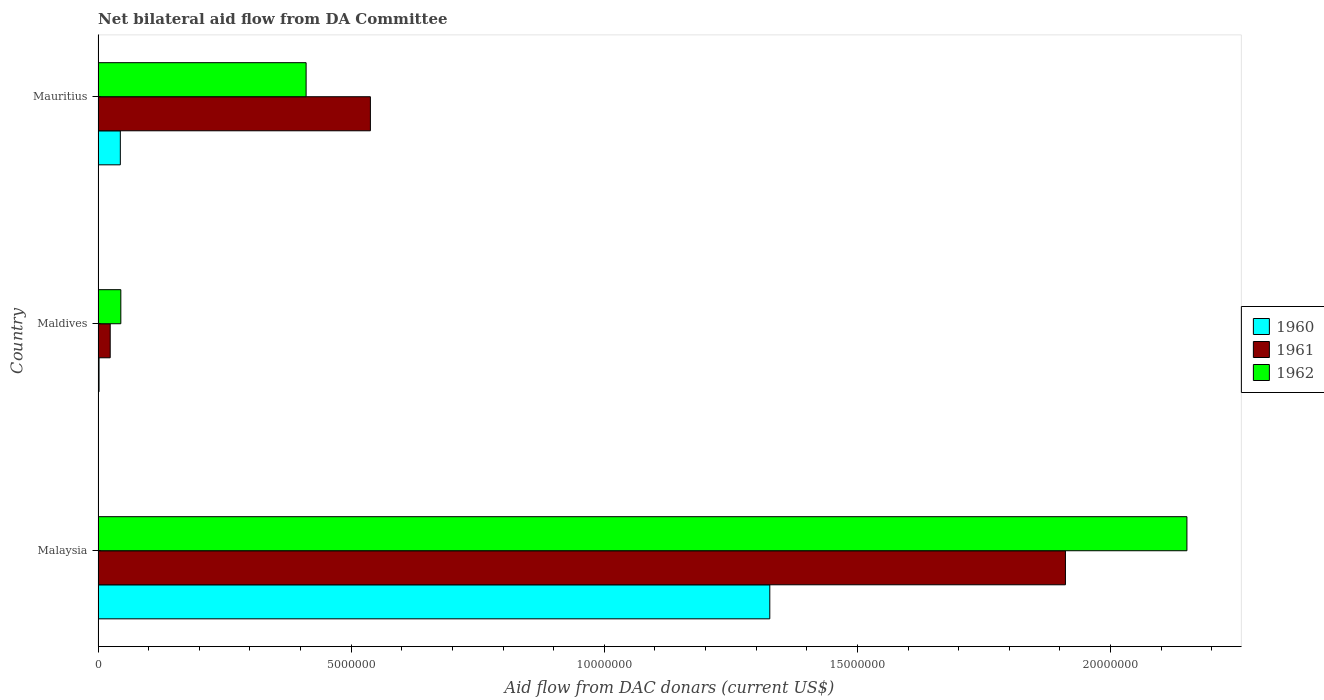How many different coloured bars are there?
Your answer should be compact. 3. How many groups of bars are there?
Your answer should be very brief. 3. How many bars are there on the 3rd tick from the top?
Keep it short and to the point. 3. What is the label of the 3rd group of bars from the top?
Keep it short and to the point. Malaysia. What is the aid flow in in 1962 in Mauritius?
Provide a succinct answer. 4.11e+06. Across all countries, what is the maximum aid flow in in 1960?
Provide a succinct answer. 1.33e+07. In which country was the aid flow in in 1960 maximum?
Give a very brief answer. Malaysia. In which country was the aid flow in in 1960 minimum?
Give a very brief answer. Maldives. What is the total aid flow in in 1961 in the graph?
Your answer should be compact. 2.47e+07. What is the difference between the aid flow in in 1960 in Maldives and that in Mauritius?
Provide a succinct answer. -4.20e+05. What is the difference between the aid flow in in 1961 in Mauritius and the aid flow in in 1960 in Malaysia?
Your answer should be compact. -7.89e+06. What is the average aid flow in in 1961 per country?
Ensure brevity in your answer.  8.24e+06. What is the difference between the aid flow in in 1960 and aid flow in in 1961 in Malaysia?
Offer a very short reply. -5.84e+06. In how many countries, is the aid flow in in 1962 greater than 2000000 US$?
Make the answer very short. 2. What is the ratio of the aid flow in in 1961 in Malaysia to that in Mauritius?
Provide a succinct answer. 3.55. Is the aid flow in in 1962 in Maldives less than that in Mauritius?
Keep it short and to the point. Yes. What is the difference between the highest and the second highest aid flow in in 1960?
Your answer should be very brief. 1.28e+07. What is the difference between the highest and the lowest aid flow in in 1962?
Your response must be concise. 2.11e+07. What does the 1st bar from the bottom in Malaysia represents?
Keep it short and to the point. 1960. Are all the bars in the graph horizontal?
Offer a terse response. Yes. Where does the legend appear in the graph?
Offer a terse response. Center right. What is the title of the graph?
Make the answer very short. Net bilateral aid flow from DA Committee. What is the label or title of the X-axis?
Offer a terse response. Aid flow from DAC donars (current US$). What is the label or title of the Y-axis?
Offer a very short reply. Country. What is the Aid flow from DAC donars (current US$) of 1960 in Malaysia?
Your answer should be compact. 1.33e+07. What is the Aid flow from DAC donars (current US$) in 1961 in Malaysia?
Your response must be concise. 1.91e+07. What is the Aid flow from DAC donars (current US$) in 1962 in Malaysia?
Provide a succinct answer. 2.15e+07. What is the Aid flow from DAC donars (current US$) of 1961 in Maldives?
Provide a short and direct response. 2.40e+05. What is the Aid flow from DAC donars (current US$) of 1961 in Mauritius?
Keep it short and to the point. 5.38e+06. What is the Aid flow from DAC donars (current US$) in 1962 in Mauritius?
Offer a very short reply. 4.11e+06. Across all countries, what is the maximum Aid flow from DAC donars (current US$) in 1960?
Your answer should be compact. 1.33e+07. Across all countries, what is the maximum Aid flow from DAC donars (current US$) in 1961?
Offer a very short reply. 1.91e+07. Across all countries, what is the maximum Aid flow from DAC donars (current US$) of 1962?
Provide a succinct answer. 2.15e+07. Across all countries, what is the minimum Aid flow from DAC donars (current US$) of 1960?
Provide a succinct answer. 2.00e+04. Across all countries, what is the minimum Aid flow from DAC donars (current US$) of 1962?
Your answer should be compact. 4.50e+05. What is the total Aid flow from DAC donars (current US$) of 1960 in the graph?
Keep it short and to the point. 1.37e+07. What is the total Aid flow from DAC donars (current US$) in 1961 in the graph?
Your answer should be very brief. 2.47e+07. What is the total Aid flow from DAC donars (current US$) in 1962 in the graph?
Offer a terse response. 2.61e+07. What is the difference between the Aid flow from DAC donars (current US$) of 1960 in Malaysia and that in Maldives?
Offer a terse response. 1.32e+07. What is the difference between the Aid flow from DAC donars (current US$) in 1961 in Malaysia and that in Maldives?
Offer a very short reply. 1.89e+07. What is the difference between the Aid flow from DAC donars (current US$) of 1962 in Malaysia and that in Maldives?
Make the answer very short. 2.11e+07. What is the difference between the Aid flow from DAC donars (current US$) of 1960 in Malaysia and that in Mauritius?
Keep it short and to the point. 1.28e+07. What is the difference between the Aid flow from DAC donars (current US$) of 1961 in Malaysia and that in Mauritius?
Give a very brief answer. 1.37e+07. What is the difference between the Aid flow from DAC donars (current US$) in 1962 in Malaysia and that in Mauritius?
Offer a terse response. 1.74e+07. What is the difference between the Aid flow from DAC donars (current US$) in 1960 in Maldives and that in Mauritius?
Offer a very short reply. -4.20e+05. What is the difference between the Aid flow from DAC donars (current US$) of 1961 in Maldives and that in Mauritius?
Your response must be concise. -5.14e+06. What is the difference between the Aid flow from DAC donars (current US$) in 1962 in Maldives and that in Mauritius?
Provide a succinct answer. -3.66e+06. What is the difference between the Aid flow from DAC donars (current US$) of 1960 in Malaysia and the Aid flow from DAC donars (current US$) of 1961 in Maldives?
Your answer should be compact. 1.30e+07. What is the difference between the Aid flow from DAC donars (current US$) in 1960 in Malaysia and the Aid flow from DAC donars (current US$) in 1962 in Maldives?
Provide a succinct answer. 1.28e+07. What is the difference between the Aid flow from DAC donars (current US$) in 1961 in Malaysia and the Aid flow from DAC donars (current US$) in 1962 in Maldives?
Your answer should be compact. 1.87e+07. What is the difference between the Aid flow from DAC donars (current US$) of 1960 in Malaysia and the Aid flow from DAC donars (current US$) of 1961 in Mauritius?
Provide a succinct answer. 7.89e+06. What is the difference between the Aid flow from DAC donars (current US$) in 1960 in Malaysia and the Aid flow from DAC donars (current US$) in 1962 in Mauritius?
Keep it short and to the point. 9.16e+06. What is the difference between the Aid flow from DAC donars (current US$) of 1961 in Malaysia and the Aid flow from DAC donars (current US$) of 1962 in Mauritius?
Your answer should be compact. 1.50e+07. What is the difference between the Aid flow from DAC donars (current US$) in 1960 in Maldives and the Aid flow from DAC donars (current US$) in 1961 in Mauritius?
Your answer should be very brief. -5.36e+06. What is the difference between the Aid flow from DAC donars (current US$) of 1960 in Maldives and the Aid flow from DAC donars (current US$) of 1962 in Mauritius?
Provide a succinct answer. -4.09e+06. What is the difference between the Aid flow from DAC donars (current US$) of 1961 in Maldives and the Aid flow from DAC donars (current US$) of 1962 in Mauritius?
Ensure brevity in your answer.  -3.87e+06. What is the average Aid flow from DAC donars (current US$) of 1960 per country?
Offer a terse response. 4.58e+06. What is the average Aid flow from DAC donars (current US$) in 1961 per country?
Offer a very short reply. 8.24e+06. What is the average Aid flow from DAC donars (current US$) in 1962 per country?
Ensure brevity in your answer.  8.69e+06. What is the difference between the Aid flow from DAC donars (current US$) in 1960 and Aid flow from DAC donars (current US$) in 1961 in Malaysia?
Give a very brief answer. -5.84e+06. What is the difference between the Aid flow from DAC donars (current US$) in 1960 and Aid flow from DAC donars (current US$) in 1962 in Malaysia?
Give a very brief answer. -8.24e+06. What is the difference between the Aid flow from DAC donars (current US$) of 1961 and Aid flow from DAC donars (current US$) of 1962 in Malaysia?
Offer a very short reply. -2.40e+06. What is the difference between the Aid flow from DAC donars (current US$) in 1960 and Aid flow from DAC donars (current US$) in 1962 in Maldives?
Provide a succinct answer. -4.30e+05. What is the difference between the Aid flow from DAC donars (current US$) in 1960 and Aid flow from DAC donars (current US$) in 1961 in Mauritius?
Your response must be concise. -4.94e+06. What is the difference between the Aid flow from DAC donars (current US$) in 1960 and Aid flow from DAC donars (current US$) in 1962 in Mauritius?
Give a very brief answer. -3.67e+06. What is the difference between the Aid flow from DAC donars (current US$) in 1961 and Aid flow from DAC donars (current US$) in 1962 in Mauritius?
Give a very brief answer. 1.27e+06. What is the ratio of the Aid flow from DAC donars (current US$) in 1960 in Malaysia to that in Maldives?
Make the answer very short. 663.5. What is the ratio of the Aid flow from DAC donars (current US$) of 1961 in Malaysia to that in Maldives?
Ensure brevity in your answer.  79.62. What is the ratio of the Aid flow from DAC donars (current US$) in 1962 in Malaysia to that in Maldives?
Give a very brief answer. 47.8. What is the ratio of the Aid flow from DAC donars (current US$) in 1960 in Malaysia to that in Mauritius?
Your answer should be compact. 30.16. What is the ratio of the Aid flow from DAC donars (current US$) in 1961 in Malaysia to that in Mauritius?
Your answer should be very brief. 3.55. What is the ratio of the Aid flow from DAC donars (current US$) in 1962 in Malaysia to that in Mauritius?
Keep it short and to the point. 5.23. What is the ratio of the Aid flow from DAC donars (current US$) of 1960 in Maldives to that in Mauritius?
Give a very brief answer. 0.05. What is the ratio of the Aid flow from DAC donars (current US$) in 1961 in Maldives to that in Mauritius?
Give a very brief answer. 0.04. What is the ratio of the Aid flow from DAC donars (current US$) of 1962 in Maldives to that in Mauritius?
Ensure brevity in your answer.  0.11. What is the difference between the highest and the second highest Aid flow from DAC donars (current US$) in 1960?
Keep it short and to the point. 1.28e+07. What is the difference between the highest and the second highest Aid flow from DAC donars (current US$) in 1961?
Keep it short and to the point. 1.37e+07. What is the difference between the highest and the second highest Aid flow from DAC donars (current US$) of 1962?
Your response must be concise. 1.74e+07. What is the difference between the highest and the lowest Aid flow from DAC donars (current US$) of 1960?
Keep it short and to the point. 1.32e+07. What is the difference between the highest and the lowest Aid flow from DAC donars (current US$) of 1961?
Your answer should be compact. 1.89e+07. What is the difference between the highest and the lowest Aid flow from DAC donars (current US$) in 1962?
Provide a succinct answer. 2.11e+07. 